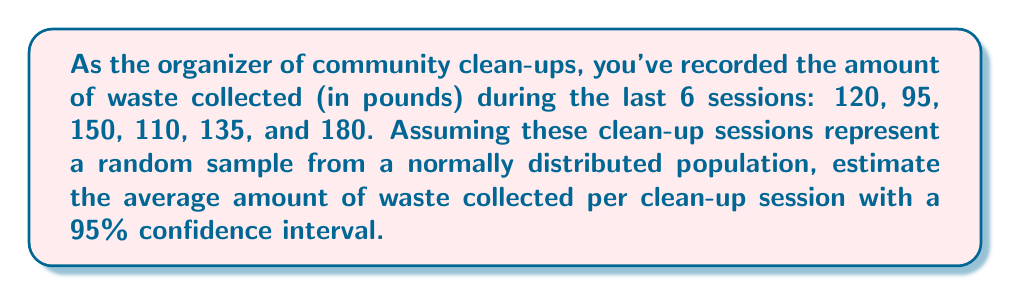Give your solution to this math problem. To estimate the average amount of waste collected with a 95% confidence interval, we'll follow these steps:

1. Calculate the sample mean ($\bar{x}$):
   $$\bar{x} = \frac{120 + 95 + 150 + 110 + 135 + 180}{6} = 131.67$$

2. Calculate the sample standard deviation ($s$):
   $$s = \sqrt{\frac{\sum_{i=1}^{n} (x_i - \bar{x})^2}{n - 1}}$$
   $$s = \sqrt{\frac{(120-131.67)^2 + (95-131.67)^2 + ... + (180-131.67)^2}{5}} \approx 31.41$$

3. Determine the t-value for a 95% confidence interval with 5 degrees of freedom (n-1):
   $t_{0.025,5} = 2.571$ (from t-distribution table)

4. Calculate the margin of error:
   $$\text{Margin of Error} = t_{0.025,5} \cdot \frac{s}{\sqrt{n}} = 2.571 \cdot \frac{31.41}{\sqrt{6}} \approx 32.97$$

5. Construct the confidence interval:
   $$\text{CI} = \bar{x} \pm \text{Margin of Error}$$
   $$\text{CI} = 131.67 \pm 32.97$$
   $$\text{CI} = (98.70, 164.64)$$

Therefore, we can estimate with 95% confidence that the true average amount of waste collected per clean-up session is between 98.70 and 164.64 pounds.
Answer: 95% CI: (98.70, 164.64) pounds 